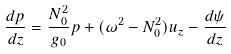Convert formula to latex. <formula><loc_0><loc_0><loc_500><loc_500>\frac { d p } { d z } = \frac { N _ { 0 } ^ { 2 } } { g _ { 0 } } p + ( \omega ^ { 2 } - N _ { 0 } ^ { 2 } ) u _ { z } - \frac { d \psi } { d z }</formula> 